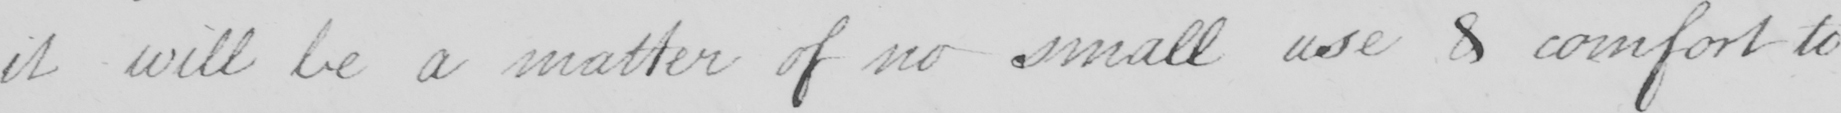What text is written in this handwritten line? it will be a matter of no small use & comfort to 